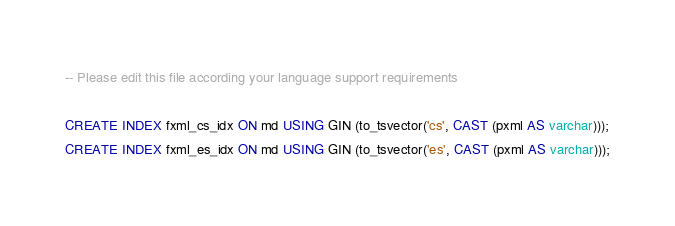Convert code to text. <code><loc_0><loc_0><loc_500><loc_500><_SQL_>-- Please edit this file according your language support requirements

CREATE INDEX fxml_cs_idx ON md USING GIN (to_tsvector('cs', CAST (pxml AS varchar)));
CREATE INDEX fxml_es_idx ON md USING GIN (to_tsvector('es', CAST (pxml AS varchar)));
</code> 